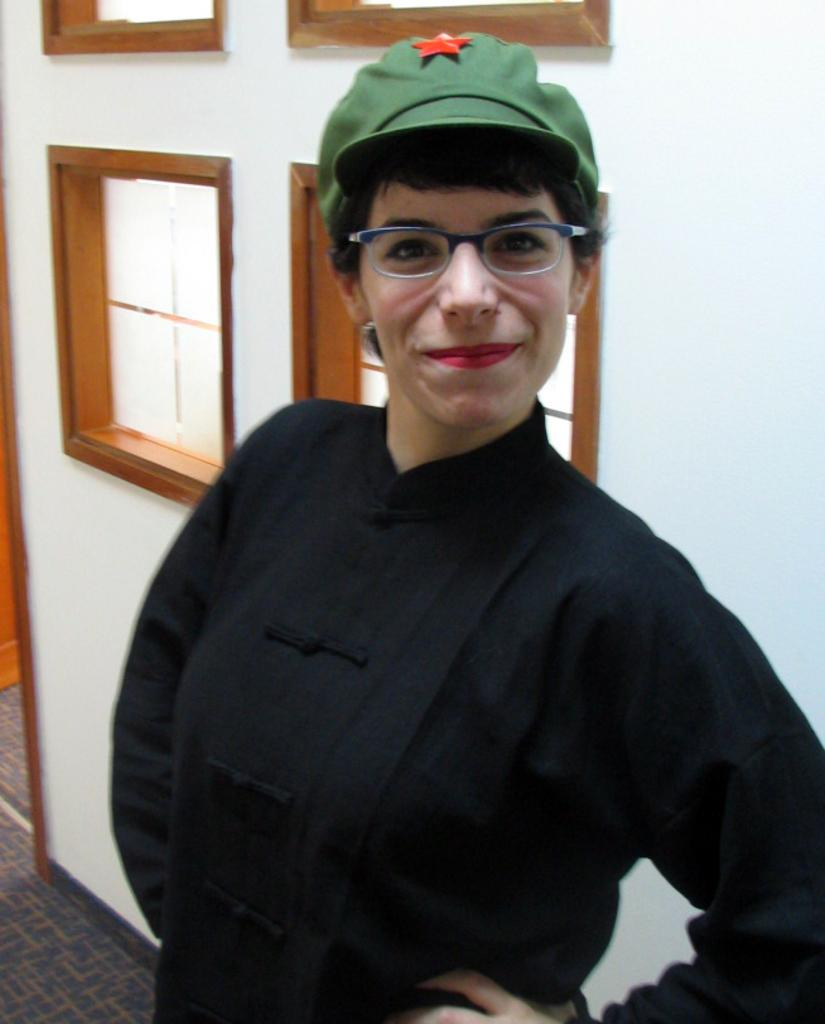Who is the main subject in the image? There is a woman in the image. What is the woman wearing? The woman is wearing a black dress, specs, and a cap. What is visible behind the woman? There are windows behind the woman. What is the woman's posture in the image? The woman is standing. Can you see a stream flowing behind the woman in the image? There is no stream visible in the image; only windows are present behind the woman. 